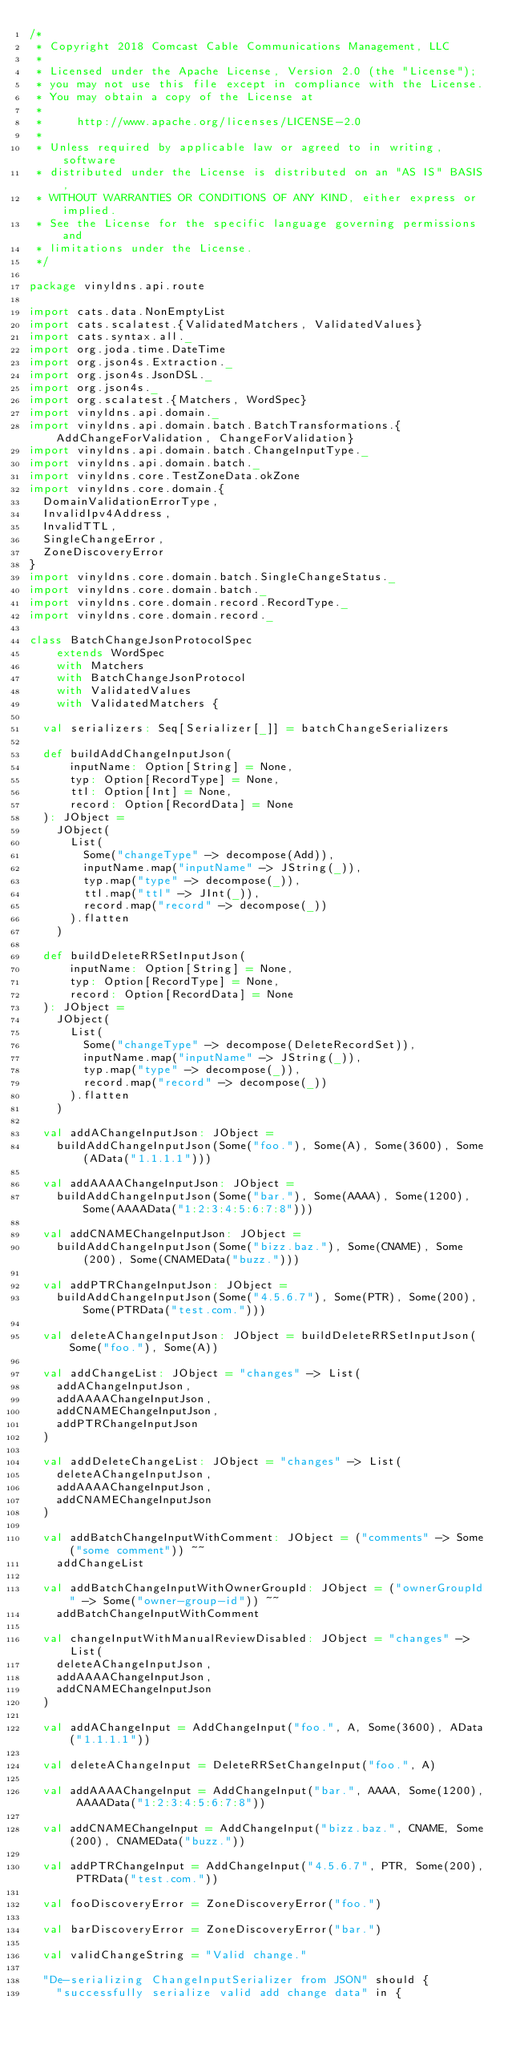<code> <loc_0><loc_0><loc_500><loc_500><_Scala_>/*
 * Copyright 2018 Comcast Cable Communications Management, LLC
 *
 * Licensed under the Apache License, Version 2.0 (the "License");
 * you may not use this file except in compliance with the License.
 * You may obtain a copy of the License at
 *
 *     http://www.apache.org/licenses/LICENSE-2.0
 *
 * Unless required by applicable law or agreed to in writing, software
 * distributed under the License is distributed on an "AS IS" BASIS,
 * WITHOUT WARRANTIES OR CONDITIONS OF ANY KIND, either express or implied.
 * See the License for the specific language governing permissions and
 * limitations under the License.
 */

package vinyldns.api.route

import cats.data.NonEmptyList
import cats.scalatest.{ValidatedMatchers, ValidatedValues}
import cats.syntax.all._
import org.joda.time.DateTime
import org.json4s.Extraction._
import org.json4s.JsonDSL._
import org.json4s._
import org.scalatest.{Matchers, WordSpec}
import vinyldns.api.domain._
import vinyldns.api.domain.batch.BatchTransformations.{AddChangeForValidation, ChangeForValidation}
import vinyldns.api.domain.batch.ChangeInputType._
import vinyldns.api.domain.batch._
import vinyldns.core.TestZoneData.okZone
import vinyldns.core.domain.{
  DomainValidationErrorType,
  InvalidIpv4Address,
  InvalidTTL,
  SingleChangeError,
  ZoneDiscoveryError
}
import vinyldns.core.domain.batch.SingleChangeStatus._
import vinyldns.core.domain.batch._
import vinyldns.core.domain.record.RecordType._
import vinyldns.core.domain.record._

class BatchChangeJsonProtocolSpec
    extends WordSpec
    with Matchers
    with BatchChangeJsonProtocol
    with ValidatedValues
    with ValidatedMatchers {

  val serializers: Seq[Serializer[_]] = batchChangeSerializers

  def buildAddChangeInputJson(
      inputName: Option[String] = None,
      typ: Option[RecordType] = None,
      ttl: Option[Int] = None,
      record: Option[RecordData] = None
  ): JObject =
    JObject(
      List(
        Some("changeType" -> decompose(Add)),
        inputName.map("inputName" -> JString(_)),
        typ.map("type" -> decompose(_)),
        ttl.map("ttl" -> JInt(_)),
        record.map("record" -> decompose(_))
      ).flatten
    )

  def buildDeleteRRSetInputJson(
      inputName: Option[String] = None,
      typ: Option[RecordType] = None,
      record: Option[RecordData] = None
  ): JObject =
    JObject(
      List(
        Some("changeType" -> decompose(DeleteRecordSet)),
        inputName.map("inputName" -> JString(_)),
        typ.map("type" -> decompose(_)),
        record.map("record" -> decompose(_))
      ).flatten
    )

  val addAChangeInputJson: JObject =
    buildAddChangeInputJson(Some("foo."), Some(A), Some(3600), Some(AData("1.1.1.1")))

  val addAAAAChangeInputJson: JObject =
    buildAddChangeInputJson(Some("bar."), Some(AAAA), Some(1200), Some(AAAAData("1:2:3:4:5:6:7:8")))

  val addCNAMEChangeInputJson: JObject =
    buildAddChangeInputJson(Some("bizz.baz."), Some(CNAME), Some(200), Some(CNAMEData("buzz.")))

  val addPTRChangeInputJson: JObject =
    buildAddChangeInputJson(Some("4.5.6.7"), Some(PTR), Some(200), Some(PTRData("test.com.")))

  val deleteAChangeInputJson: JObject = buildDeleteRRSetInputJson(Some("foo."), Some(A))

  val addChangeList: JObject = "changes" -> List(
    addAChangeInputJson,
    addAAAAChangeInputJson,
    addCNAMEChangeInputJson,
    addPTRChangeInputJson
  )

  val addDeleteChangeList: JObject = "changes" -> List(
    deleteAChangeInputJson,
    addAAAAChangeInputJson,
    addCNAMEChangeInputJson
  )

  val addBatchChangeInputWithComment: JObject = ("comments" -> Some("some comment")) ~~
    addChangeList

  val addBatchChangeInputWithOwnerGroupId: JObject = ("ownerGroupId" -> Some("owner-group-id")) ~~
    addBatchChangeInputWithComment

  val changeInputWithManualReviewDisabled: JObject = "changes" -> List(
    deleteAChangeInputJson,
    addAAAAChangeInputJson,
    addCNAMEChangeInputJson
  )

  val addAChangeInput = AddChangeInput("foo.", A, Some(3600), AData("1.1.1.1"))

  val deleteAChangeInput = DeleteRRSetChangeInput("foo.", A)

  val addAAAAChangeInput = AddChangeInput("bar.", AAAA, Some(1200), AAAAData("1:2:3:4:5:6:7:8"))

  val addCNAMEChangeInput = AddChangeInput("bizz.baz.", CNAME, Some(200), CNAMEData("buzz."))

  val addPTRChangeInput = AddChangeInput("4.5.6.7", PTR, Some(200), PTRData("test.com."))

  val fooDiscoveryError = ZoneDiscoveryError("foo.")

  val barDiscoveryError = ZoneDiscoveryError("bar.")

  val validChangeString = "Valid change."

  "De-serializing ChangeInputSerializer from JSON" should {
    "successfully serialize valid add change data" in {</code> 